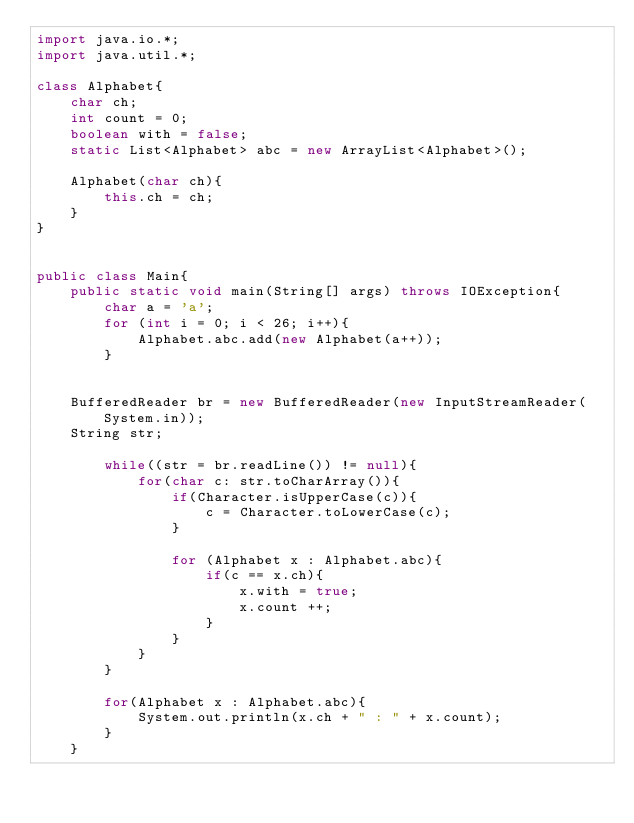<code> <loc_0><loc_0><loc_500><loc_500><_Java_>import java.io.*;
import java.util.*;

class Alphabet{
	char ch;
	int count = 0;
	boolean with = false;
	static List<Alphabet> abc = new ArrayList<Alphabet>();

	Alphabet(char ch){
		this.ch = ch;
	}
}


public class Main{
	public static void main(String[] args) throws IOException{
		char a = 'a';
		for (int i = 0; i < 26; i++){
			Alphabet.abc.add(new Alphabet(a++));
		}

				
	BufferedReader br = new BufferedReader(new InputStreamReader(System.in));
	String str;
	
		while((str = br.readLine()) != null){
			for(char c: str.toCharArray()){
				if(Character.isUpperCase(c)){
					c = Character.toLowerCase(c);
				}

				for (Alphabet x : Alphabet.abc){
					if(c == x.ch){
						x.with = true;
						x.count ++;
					}	
				}
			}
		}			

		for(Alphabet x : Alphabet.abc){
			System.out.println(x.ch + " : " + x.count);
		}
	}</code> 